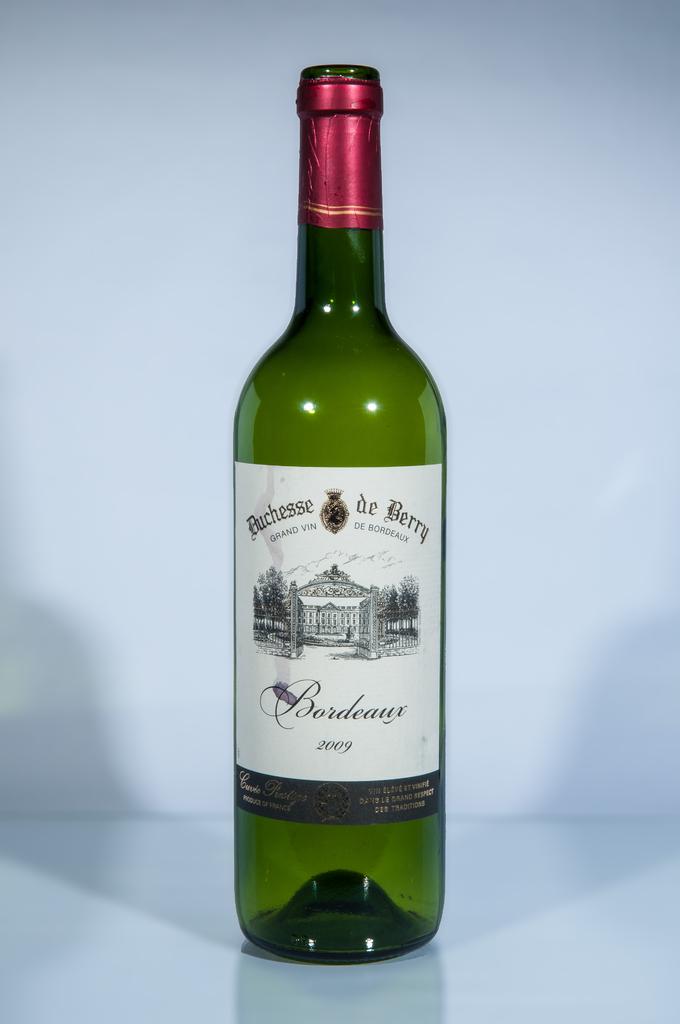What is the year of this wine?
Provide a short and direct response. 2009. What is the winery name?
Your answer should be very brief. Duchesse de berry. 